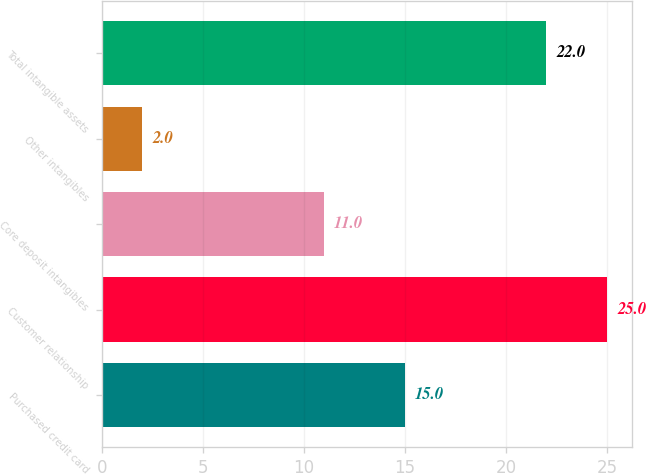Convert chart. <chart><loc_0><loc_0><loc_500><loc_500><bar_chart><fcel>Purchased credit card<fcel>Customer relationship<fcel>Core deposit intangibles<fcel>Other intangibles<fcel>Total intangible assets<nl><fcel>15<fcel>25<fcel>11<fcel>2<fcel>22<nl></chart> 